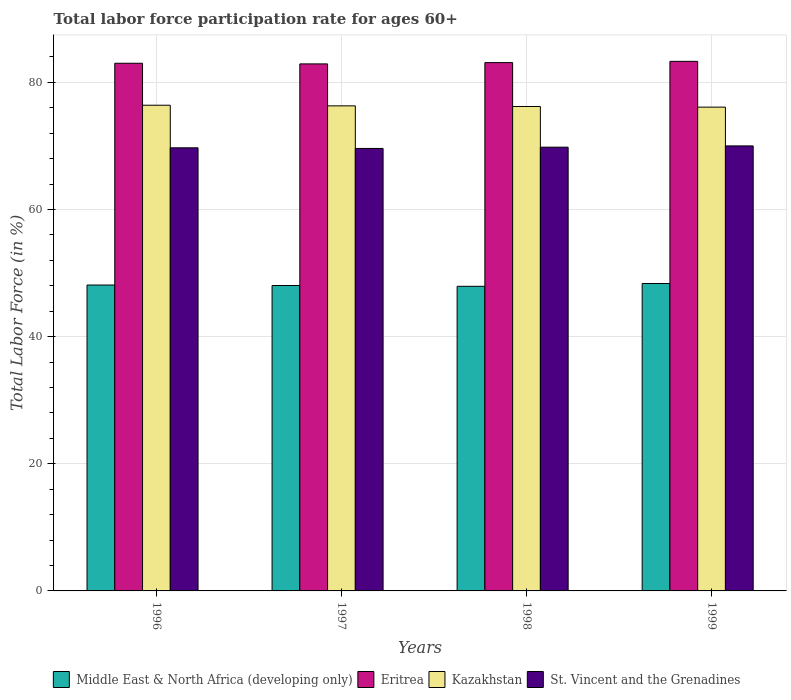Are the number of bars per tick equal to the number of legend labels?
Provide a succinct answer. Yes. Are the number of bars on each tick of the X-axis equal?
Keep it short and to the point. Yes. How many bars are there on the 1st tick from the left?
Your response must be concise. 4. How many bars are there on the 1st tick from the right?
Make the answer very short. 4. What is the label of the 4th group of bars from the left?
Keep it short and to the point. 1999. What is the labor force participation rate in Middle East & North Africa (developing only) in 1997?
Your answer should be compact. 48.04. Across all years, what is the maximum labor force participation rate in Middle East & North Africa (developing only)?
Provide a succinct answer. 48.36. Across all years, what is the minimum labor force participation rate in St. Vincent and the Grenadines?
Your answer should be very brief. 69.6. In which year was the labor force participation rate in St. Vincent and the Grenadines maximum?
Ensure brevity in your answer.  1999. What is the total labor force participation rate in Kazakhstan in the graph?
Offer a very short reply. 305. What is the difference between the labor force participation rate in St. Vincent and the Grenadines in 1996 and that in 1997?
Ensure brevity in your answer.  0.1. What is the difference between the labor force participation rate in Middle East & North Africa (developing only) in 1998 and the labor force participation rate in Eritrea in 1997?
Offer a terse response. -34.98. What is the average labor force participation rate in Eritrea per year?
Give a very brief answer. 83.08. In the year 1999, what is the difference between the labor force participation rate in Kazakhstan and labor force participation rate in Eritrea?
Your answer should be very brief. -7.2. What is the ratio of the labor force participation rate in Middle East & North Africa (developing only) in 1996 to that in 1999?
Offer a very short reply. 1. What is the difference between the highest and the second highest labor force participation rate in St. Vincent and the Grenadines?
Your answer should be compact. 0.2. What is the difference between the highest and the lowest labor force participation rate in St. Vincent and the Grenadines?
Offer a very short reply. 0.4. Is it the case that in every year, the sum of the labor force participation rate in Middle East & North Africa (developing only) and labor force participation rate in St. Vincent and the Grenadines is greater than the sum of labor force participation rate in Kazakhstan and labor force participation rate in Eritrea?
Your response must be concise. No. What does the 4th bar from the left in 1997 represents?
Provide a succinct answer. St. Vincent and the Grenadines. What does the 2nd bar from the right in 1998 represents?
Offer a terse response. Kazakhstan. Are all the bars in the graph horizontal?
Ensure brevity in your answer.  No. Are the values on the major ticks of Y-axis written in scientific E-notation?
Your response must be concise. No. Does the graph contain any zero values?
Keep it short and to the point. No. Does the graph contain grids?
Ensure brevity in your answer.  Yes. How are the legend labels stacked?
Your response must be concise. Horizontal. What is the title of the graph?
Offer a terse response. Total labor force participation rate for ages 60+. Does "Grenada" appear as one of the legend labels in the graph?
Your answer should be very brief. No. What is the label or title of the X-axis?
Ensure brevity in your answer.  Years. What is the label or title of the Y-axis?
Keep it short and to the point. Total Labor Force (in %). What is the Total Labor Force (in %) in Middle East & North Africa (developing only) in 1996?
Keep it short and to the point. 48.12. What is the Total Labor Force (in %) in Kazakhstan in 1996?
Your response must be concise. 76.4. What is the Total Labor Force (in %) in St. Vincent and the Grenadines in 1996?
Keep it short and to the point. 69.7. What is the Total Labor Force (in %) in Middle East & North Africa (developing only) in 1997?
Provide a succinct answer. 48.04. What is the Total Labor Force (in %) in Eritrea in 1997?
Offer a very short reply. 82.9. What is the Total Labor Force (in %) of Kazakhstan in 1997?
Provide a short and direct response. 76.3. What is the Total Labor Force (in %) in St. Vincent and the Grenadines in 1997?
Ensure brevity in your answer.  69.6. What is the Total Labor Force (in %) in Middle East & North Africa (developing only) in 1998?
Offer a terse response. 47.92. What is the Total Labor Force (in %) of Eritrea in 1998?
Offer a terse response. 83.1. What is the Total Labor Force (in %) in Kazakhstan in 1998?
Offer a very short reply. 76.2. What is the Total Labor Force (in %) of St. Vincent and the Grenadines in 1998?
Your answer should be very brief. 69.8. What is the Total Labor Force (in %) in Middle East & North Africa (developing only) in 1999?
Your answer should be compact. 48.36. What is the Total Labor Force (in %) of Eritrea in 1999?
Your answer should be very brief. 83.3. What is the Total Labor Force (in %) in Kazakhstan in 1999?
Provide a succinct answer. 76.1. What is the Total Labor Force (in %) in St. Vincent and the Grenadines in 1999?
Offer a very short reply. 70. Across all years, what is the maximum Total Labor Force (in %) of Middle East & North Africa (developing only)?
Your response must be concise. 48.36. Across all years, what is the maximum Total Labor Force (in %) in Eritrea?
Provide a succinct answer. 83.3. Across all years, what is the maximum Total Labor Force (in %) in Kazakhstan?
Your answer should be compact. 76.4. Across all years, what is the minimum Total Labor Force (in %) of Middle East & North Africa (developing only)?
Your answer should be very brief. 47.92. Across all years, what is the minimum Total Labor Force (in %) of Eritrea?
Offer a terse response. 82.9. Across all years, what is the minimum Total Labor Force (in %) of Kazakhstan?
Make the answer very short. 76.1. Across all years, what is the minimum Total Labor Force (in %) in St. Vincent and the Grenadines?
Keep it short and to the point. 69.6. What is the total Total Labor Force (in %) in Middle East & North Africa (developing only) in the graph?
Your answer should be compact. 192.43. What is the total Total Labor Force (in %) in Eritrea in the graph?
Your answer should be compact. 332.3. What is the total Total Labor Force (in %) of Kazakhstan in the graph?
Offer a very short reply. 305. What is the total Total Labor Force (in %) of St. Vincent and the Grenadines in the graph?
Your answer should be compact. 279.1. What is the difference between the Total Labor Force (in %) of Middle East & North Africa (developing only) in 1996 and that in 1997?
Offer a terse response. 0.08. What is the difference between the Total Labor Force (in %) in Kazakhstan in 1996 and that in 1997?
Provide a short and direct response. 0.1. What is the difference between the Total Labor Force (in %) of Middle East & North Africa (developing only) in 1996 and that in 1998?
Your answer should be compact. 0.2. What is the difference between the Total Labor Force (in %) in Eritrea in 1996 and that in 1998?
Make the answer very short. -0.1. What is the difference between the Total Labor Force (in %) in Kazakhstan in 1996 and that in 1998?
Your answer should be compact. 0.2. What is the difference between the Total Labor Force (in %) in St. Vincent and the Grenadines in 1996 and that in 1998?
Ensure brevity in your answer.  -0.1. What is the difference between the Total Labor Force (in %) in Middle East & North Africa (developing only) in 1996 and that in 1999?
Make the answer very short. -0.24. What is the difference between the Total Labor Force (in %) in Eritrea in 1996 and that in 1999?
Ensure brevity in your answer.  -0.3. What is the difference between the Total Labor Force (in %) of Middle East & North Africa (developing only) in 1997 and that in 1998?
Give a very brief answer. 0.12. What is the difference between the Total Labor Force (in %) in Kazakhstan in 1997 and that in 1998?
Make the answer very short. 0.1. What is the difference between the Total Labor Force (in %) of St. Vincent and the Grenadines in 1997 and that in 1998?
Provide a succinct answer. -0.2. What is the difference between the Total Labor Force (in %) in Middle East & North Africa (developing only) in 1997 and that in 1999?
Your response must be concise. -0.32. What is the difference between the Total Labor Force (in %) of Eritrea in 1997 and that in 1999?
Provide a short and direct response. -0.4. What is the difference between the Total Labor Force (in %) of Kazakhstan in 1997 and that in 1999?
Give a very brief answer. 0.2. What is the difference between the Total Labor Force (in %) of Middle East & North Africa (developing only) in 1998 and that in 1999?
Your answer should be compact. -0.44. What is the difference between the Total Labor Force (in %) of Middle East & North Africa (developing only) in 1996 and the Total Labor Force (in %) of Eritrea in 1997?
Make the answer very short. -34.78. What is the difference between the Total Labor Force (in %) of Middle East & North Africa (developing only) in 1996 and the Total Labor Force (in %) of Kazakhstan in 1997?
Provide a succinct answer. -28.18. What is the difference between the Total Labor Force (in %) in Middle East & North Africa (developing only) in 1996 and the Total Labor Force (in %) in St. Vincent and the Grenadines in 1997?
Give a very brief answer. -21.48. What is the difference between the Total Labor Force (in %) of Eritrea in 1996 and the Total Labor Force (in %) of Kazakhstan in 1997?
Provide a short and direct response. 6.7. What is the difference between the Total Labor Force (in %) in Eritrea in 1996 and the Total Labor Force (in %) in St. Vincent and the Grenadines in 1997?
Make the answer very short. 13.4. What is the difference between the Total Labor Force (in %) in Kazakhstan in 1996 and the Total Labor Force (in %) in St. Vincent and the Grenadines in 1997?
Make the answer very short. 6.8. What is the difference between the Total Labor Force (in %) in Middle East & North Africa (developing only) in 1996 and the Total Labor Force (in %) in Eritrea in 1998?
Make the answer very short. -34.98. What is the difference between the Total Labor Force (in %) of Middle East & North Africa (developing only) in 1996 and the Total Labor Force (in %) of Kazakhstan in 1998?
Keep it short and to the point. -28.08. What is the difference between the Total Labor Force (in %) of Middle East & North Africa (developing only) in 1996 and the Total Labor Force (in %) of St. Vincent and the Grenadines in 1998?
Offer a very short reply. -21.68. What is the difference between the Total Labor Force (in %) of Eritrea in 1996 and the Total Labor Force (in %) of Kazakhstan in 1998?
Keep it short and to the point. 6.8. What is the difference between the Total Labor Force (in %) of Eritrea in 1996 and the Total Labor Force (in %) of St. Vincent and the Grenadines in 1998?
Keep it short and to the point. 13.2. What is the difference between the Total Labor Force (in %) of Kazakhstan in 1996 and the Total Labor Force (in %) of St. Vincent and the Grenadines in 1998?
Keep it short and to the point. 6.6. What is the difference between the Total Labor Force (in %) of Middle East & North Africa (developing only) in 1996 and the Total Labor Force (in %) of Eritrea in 1999?
Keep it short and to the point. -35.18. What is the difference between the Total Labor Force (in %) of Middle East & North Africa (developing only) in 1996 and the Total Labor Force (in %) of Kazakhstan in 1999?
Ensure brevity in your answer.  -27.98. What is the difference between the Total Labor Force (in %) in Middle East & North Africa (developing only) in 1996 and the Total Labor Force (in %) in St. Vincent and the Grenadines in 1999?
Give a very brief answer. -21.88. What is the difference between the Total Labor Force (in %) in Eritrea in 1996 and the Total Labor Force (in %) in Kazakhstan in 1999?
Offer a very short reply. 6.9. What is the difference between the Total Labor Force (in %) in Kazakhstan in 1996 and the Total Labor Force (in %) in St. Vincent and the Grenadines in 1999?
Offer a very short reply. 6.4. What is the difference between the Total Labor Force (in %) of Middle East & North Africa (developing only) in 1997 and the Total Labor Force (in %) of Eritrea in 1998?
Offer a very short reply. -35.06. What is the difference between the Total Labor Force (in %) in Middle East & North Africa (developing only) in 1997 and the Total Labor Force (in %) in Kazakhstan in 1998?
Your answer should be very brief. -28.16. What is the difference between the Total Labor Force (in %) in Middle East & North Africa (developing only) in 1997 and the Total Labor Force (in %) in St. Vincent and the Grenadines in 1998?
Keep it short and to the point. -21.76. What is the difference between the Total Labor Force (in %) in Middle East & North Africa (developing only) in 1997 and the Total Labor Force (in %) in Eritrea in 1999?
Make the answer very short. -35.26. What is the difference between the Total Labor Force (in %) of Middle East & North Africa (developing only) in 1997 and the Total Labor Force (in %) of Kazakhstan in 1999?
Keep it short and to the point. -28.06. What is the difference between the Total Labor Force (in %) of Middle East & North Africa (developing only) in 1997 and the Total Labor Force (in %) of St. Vincent and the Grenadines in 1999?
Offer a terse response. -21.96. What is the difference between the Total Labor Force (in %) in Eritrea in 1997 and the Total Labor Force (in %) in Kazakhstan in 1999?
Make the answer very short. 6.8. What is the difference between the Total Labor Force (in %) of Middle East & North Africa (developing only) in 1998 and the Total Labor Force (in %) of Eritrea in 1999?
Give a very brief answer. -35.38. What is the difference between the Total Labor Force (in %) in Middle East & North Africa (developing only) in 1998 and the Total Labor Force (in %) in Kazakhstan in 1999?
Your answer should be compact. -28.18. What is the difference between the Total Labor Force (in %) of Middle East & North Africa (developing only) in 1998 and the Total Labor Force (in %) of St. Vincent and the Grenadines in 1999?
Provide a short and direct response. -22.08. What is the difference between the Total Labor Force (in %) of Eritrea in 1998 and the Total Labor Force (in %) of Kazakhstan in 1999?
Keep it short and to the point. 7. What is the difference between the Total Labor Force (in %) of Eritrea in 1998 and the Total Labor Force (in %) of St. Vincent and the Grenadines in 1999?
Make the answer very short. 13.1. What is the average Total Labor Force (in %) in Middle East & North Africa (developing only) per year?
Your answer should be very brief. 48.11. What is the average Total Labor Force (in %) of Eritrea per year?
Make the answer very short. 83.08. What is the average Total Labor Force (in %) in Kazakhstan per year?
Ensure brevity in your answer.  76.25. What is the average Total Labor Force (in %) of St. Vincent and the Grenadines per year?
Keep it short and to the point. 69.78. In the year 1996, what is the difference between the Total Labor Force (in %) in Middle East & North Africa (developing only) and Total Labor Force (in %) in Eritrea?
Provide a short and direct response. -34.88. In the year 1996, what is the difference between the Total Labor Force (in %) in Middle East & North Africa (developing only) and Total Labor Force (in %) in Kazakhstan?
Your answer should be very brief. -28.28. In the year 1996, what is the difference between the Total Labor Force (in %) in Middle East & North Africa (developing only) and Total Labor Force (in %) in St. Vincent and the Grenadines?
Ensure brevity in your answer.  -21.58. In the year 1996, what is the difference between the Total Labor Force (in %) of Eritrea and Total Labor Force (in %) of St. Vincent and the Grenadines?
Provide a short and direct response. 13.3. In the year 1997, what is the difference between the Total Labor Force (in %) in Middle East & North Africa (developing only) and Total Labor Force (in %) in Eritrea?
Give a very brief answer. -34.86. In the year 1997, what is the difference between the Total Labor Force (in %) in Middle East & North Africa (developing only) and Total Labor Force (in %) in Kazakhstan?
Offer a very short reply. -28.26. In the year 1997, what is the difference between the Total Labor Force (in %) in Middle East & North Africa (developing only) and Total Labor Force (in %) in St. Vincent and the Grenadines?
Keep it short and to the point. -21.56. In the year 1997, what is the difference between the Total Labor Force (in %) of Eritrea and Total Labor Force (in %) of St. Vincent and the Grenadines?
Your response must be concise. 13.3. In the year 1998, what is the difference between the Total Labor Force (in %) of Middle East & North Africa (developing only) and Total Labor Force (in %) of Eritrea?
Your answer should be very brief. -35.18. In the year 1998, what is the difference between the Total Labor Force (in %) in Middle East & North Africa (developing only) and Total Labor Force (in %) in Kazakhstan?
Ensure brevity in your answer.  -28.28. In the year 1998, what is the difference between the Total Labor Force (in %) in Middle East & North Africa (developing only) and Total Labor Force (in %) in St. Vincent and the Grenadines?
Make the answer very short. -21.88. In the year 1998, what is the difference between the Total Labor Force (in %) in Eritrea and Total Labor Force (in %) in Kazakhstan?
Your answer should be compact. 6.9. In the year 1999, what is the difference between the Total Labor Force (in %) in Middle East & North Africa (developing only) and Total Labor Force (in %) in Eritrea?
Give a very brief answer. -34.94. In the year 1999, what is the difference between the Total Labor Force (in %) of Middle East & North Africa (developing only) and Total Labor Force (in %) of Kazakhstan?
Ensure brevity in your answer.  -27.74. In the year 1999, what is the difference between the Total Labor Force (in %) of Middle East & North Africa (developing only) and Total Labor Force (in %) of St. Vincent and the Grenadines?
Ensure brevity in your answer.  -21.64. In the year 1999, what is the difference between the Total Labor Force (in %) of Eritrea and Total Labor Force (in %) of Kazakhstan?
Your answer should be very brief. 7.2. In the year 1999, what is the difference between the Total Labor Force (in %) of Kazakhstan and Total Labor Force (in %) of St. Vincent and the Grenadines?
Your response must be concise. 6.1. What is the ratio of the Total Labor Force (in %) of Middle East & North Africa (developing only) in 1996 to that in 1998?
Ensure brevity in your answer.  1. What is the ratio of the Total Labor Force (in %) of Eritrea in 1996 to that in 1998?
Offer a very short reply. 1. What is the ratio of the Total Labor Force (in %) of Kazakhstan in 1996 to that in 1998?
Keep it short and to the point. 1. What is the ratio of the Total Labor Force (in %) in St. Vincent and the Grenadines in 1996 to that in 1998?
Offer a very short reply. 1. What is the ratio of the Total Labor Force (in %) in St. Vincent and the Grenadines in 1996 to that in 1999?
Provide a succinct answer. 1. What is the ratio of the Total Labor Force (in %) of Middle East & North Africa (developing only) in 1997 to that in 1998?
Offer a very short reply. 1. What is the ratio of the Total Labor Force (in %) of Eritrea in 1997 to that in 1998?
Keep it short and to the point. 1. What is the ratio of the Total Labor Force (in %) of Kazakhstan in 1997 to that in 1998?
Your response must be concise. 1. What is the ratio of the Total Labor Force (in %) in St. Vincent and the Grenadines in 1997 to that in 1998?
Ensure brevity in your answer.  1. What is the ratio of the Total Labor Force (in %) in Middle East & North Africa (developing only) in 1997 to that in 1999?
Keep it short and to the point. 0.99. What is the ratio of the Total Labor Force (in %) in Kazakhstan in 1997 to that in 1999?
Keep it short and to the point. 1. What is the ratio of the Total Labor Force (in %) in Middle East & North Africa (developing only) in 1998 to that in 1999?
Provide a short and direct response. 0.99. What is the ratio of the Total Labor Force (in %) of Eritrea in 1998 to that in 1999?
Your response must be concise. 1. What is the ratio of the Total Labor Force (in %) of St. Vincent and the Grenadines in 1998 to that in 1999?
Ensure brevity in your answer.  1. What is the difference between the highest and the second highest Total Labor Force (in %) in Middle East & North Africa (developing only)?
Your answer should be compact. 0.24. What is the difference between the highest and the second highest Total Labor Force (in %) of St. Vincent and the Grenadines?
Your answer should be very brief. 0.2. What is the difference between the highest and the lowest Total Labor Force (in %) of Middle East & North Africa (developing only)?
Offer a terse response. 0.44. What is the difference between the highest and the lowest Total Labor Force (in %) of Eritrea?
Your answer should be compact. 0.4. What is the difference between the highest and the lowest Total Labor Force (in %) of St. Vincent and the Grenadines?
Your answer should be compact. 0.4. 